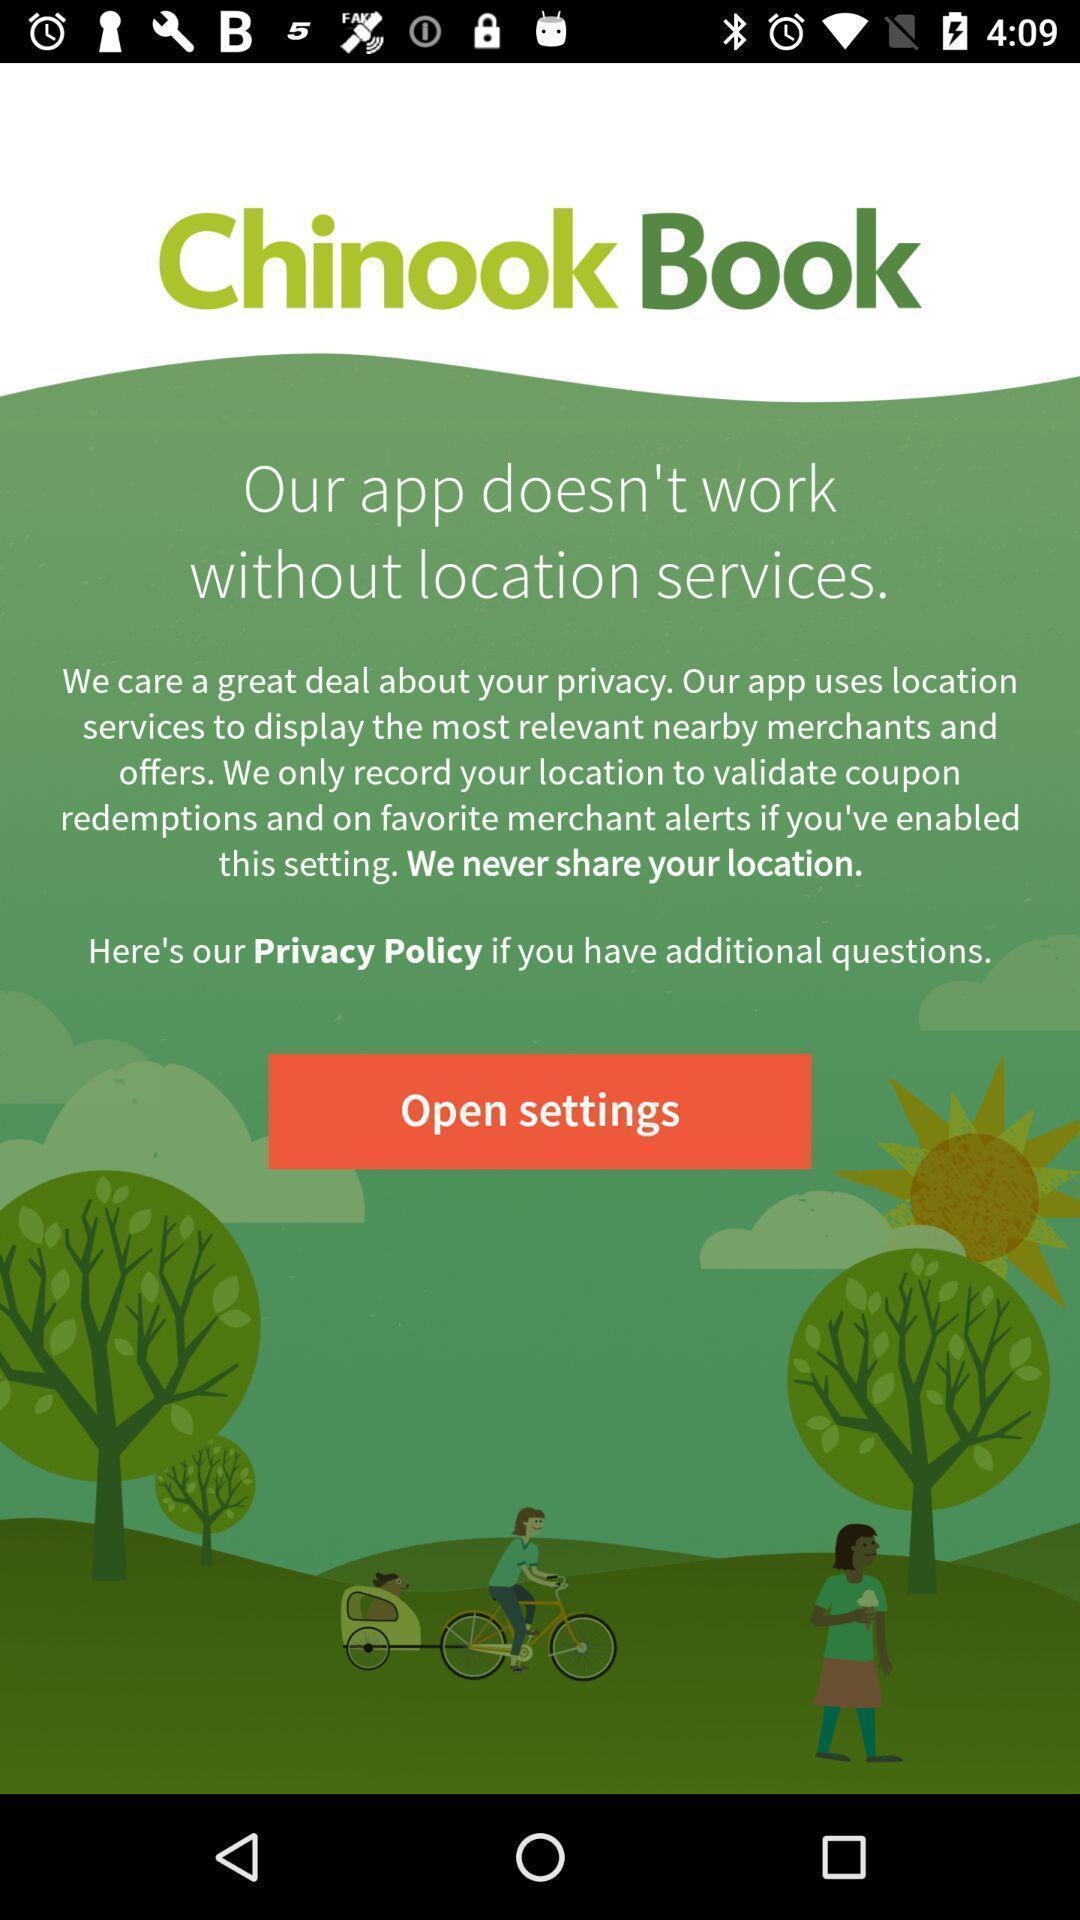What is the overall content of this screenshot? Welcome page for a places search app. 